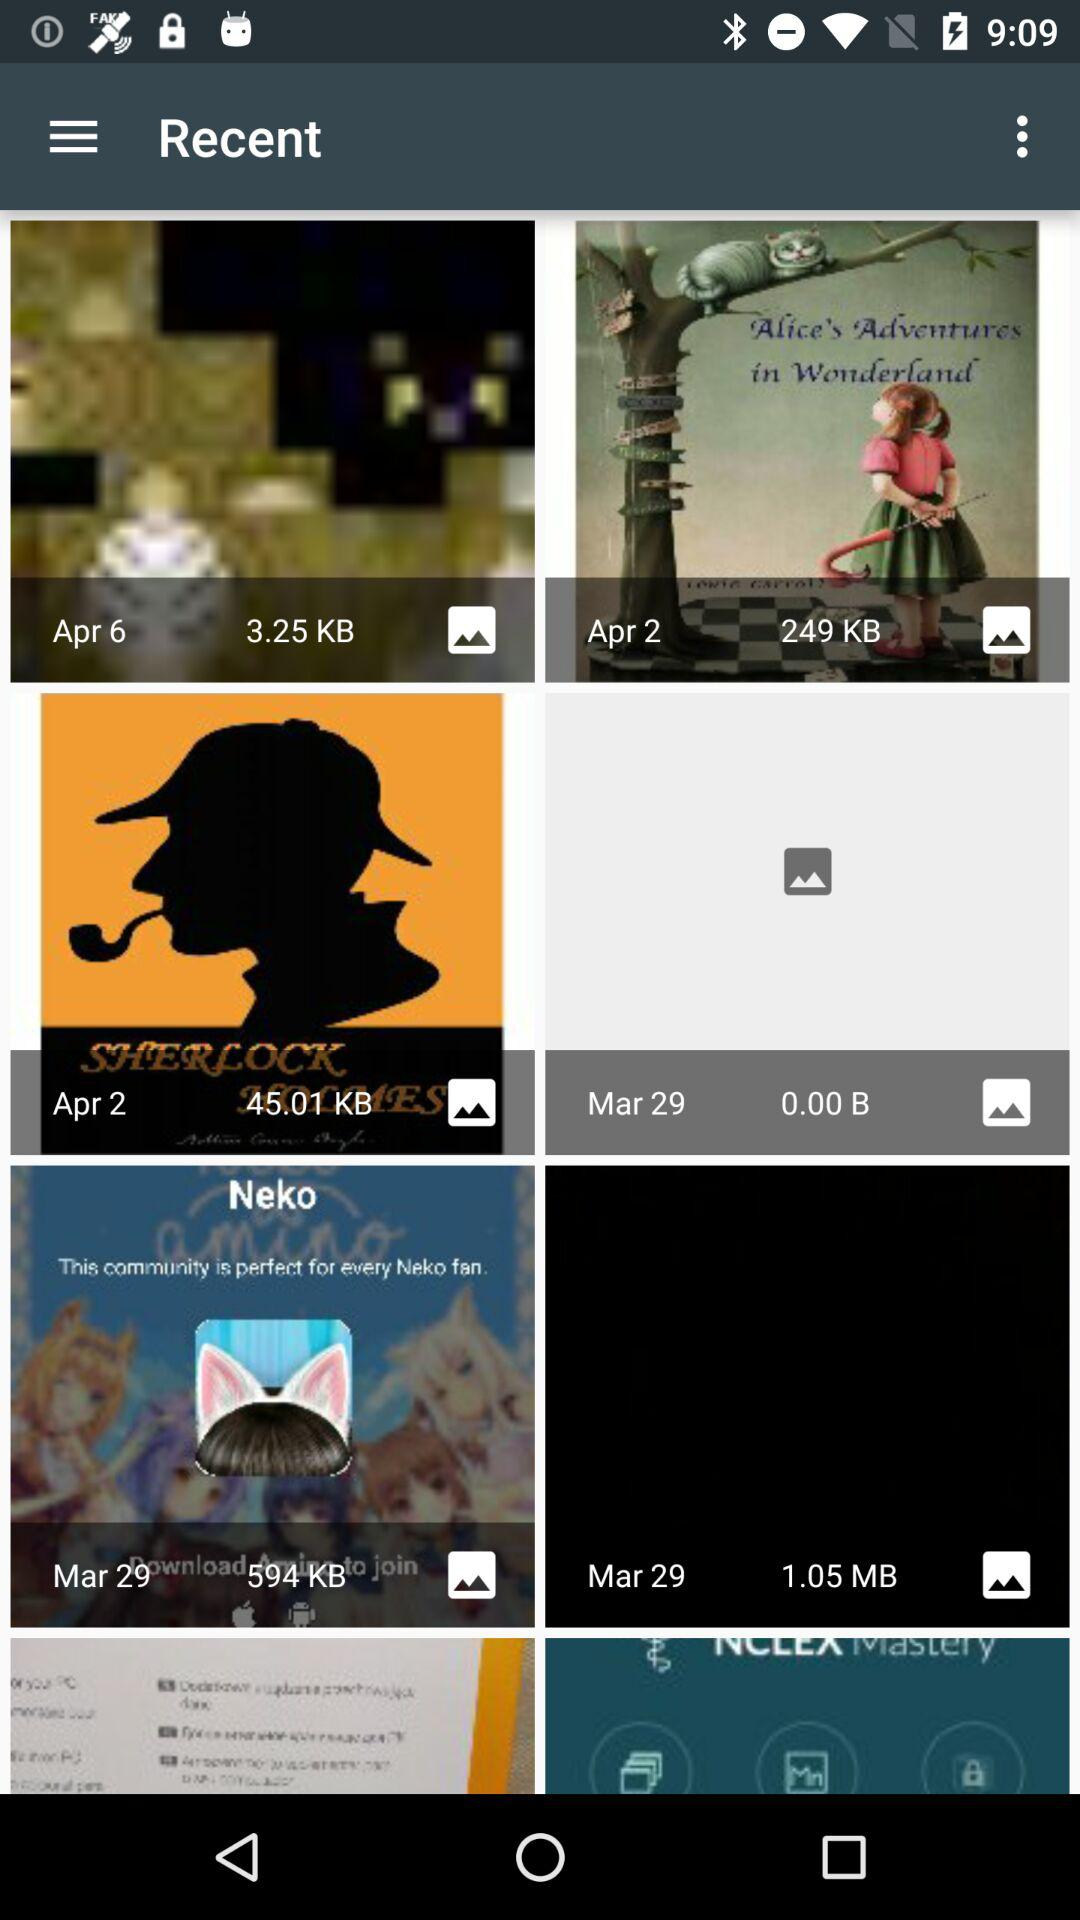What is the size of the image in Apr 6 folder? The size of the image is 3.25 KB. 